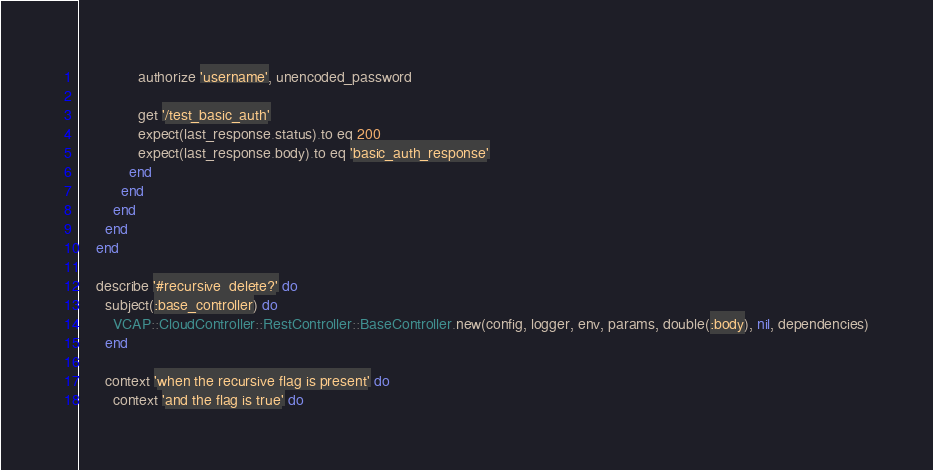Convert code to text. <code><loc_0><loc_0><loc_500><loc_500><_Ruby_>              authorize 'username', unencoded_password

              get '/test_basic_auth'
              expect(last_response.status).to eq 200
              expect(last_response.body).to eq 'basic_auth_response'
            end
          end
        end
      end
    end

    describe '#recursive_delete?' do
      subject(:base_controller) do
        VCAP::CloudController::RestController::BaseController.new(config, logger, env, params, double(:body), nil, dependencies)
      end

      context 'when the recursive flag is present' do
        context 'and the flag is true' do</code> 